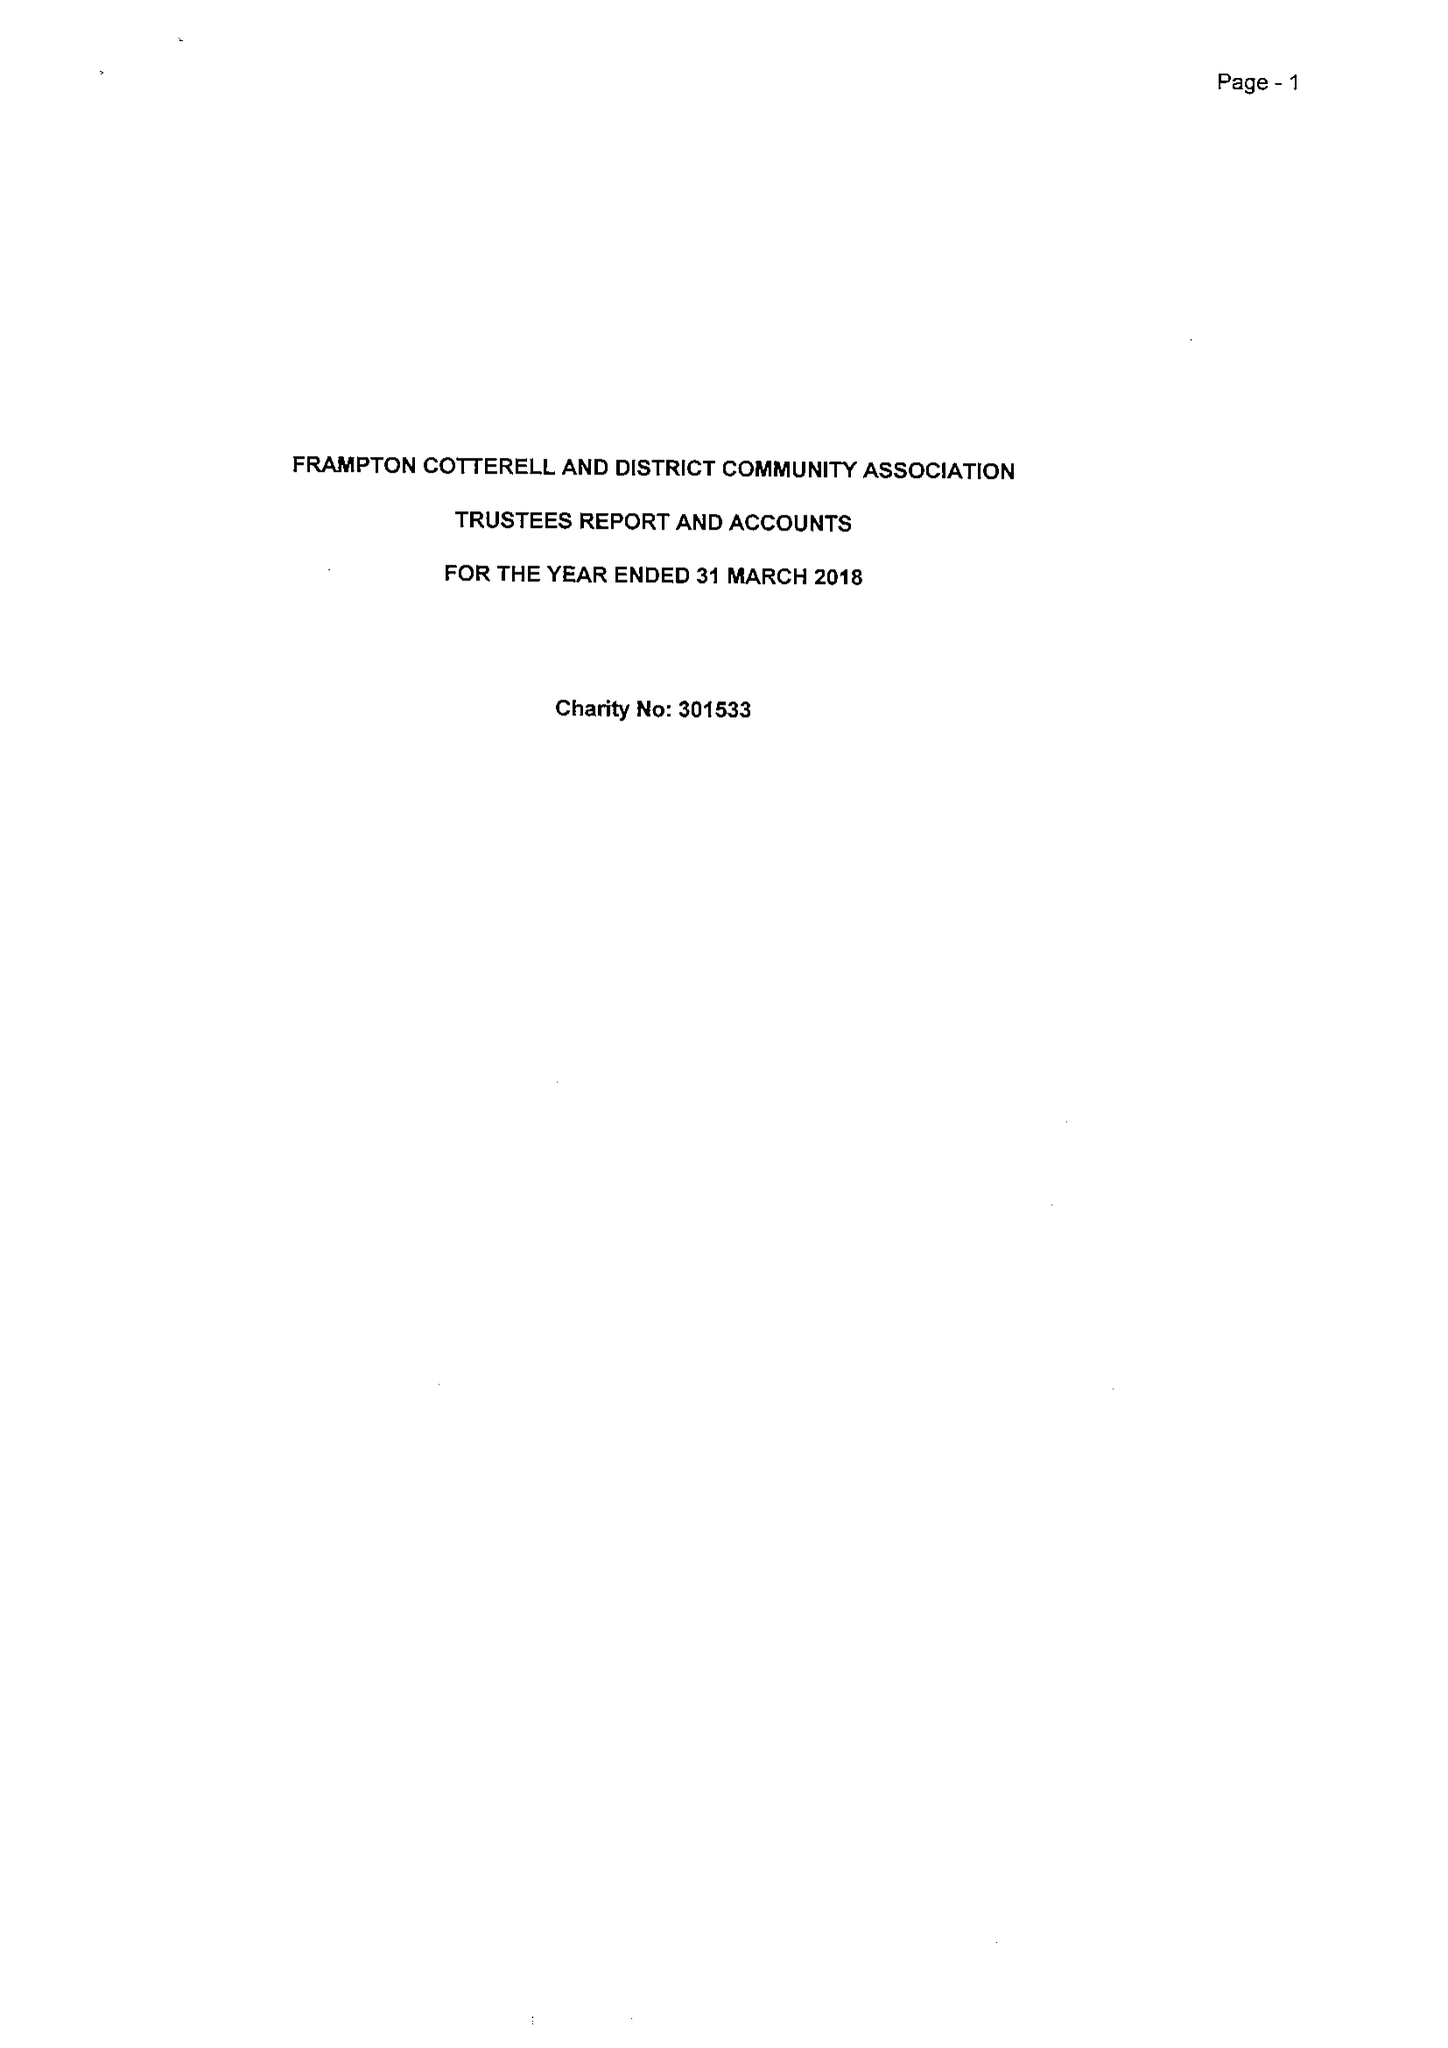What is the value for the charity_name?
Answer the question using a single word or phrase. Frampton Cotterell and District Community Association 